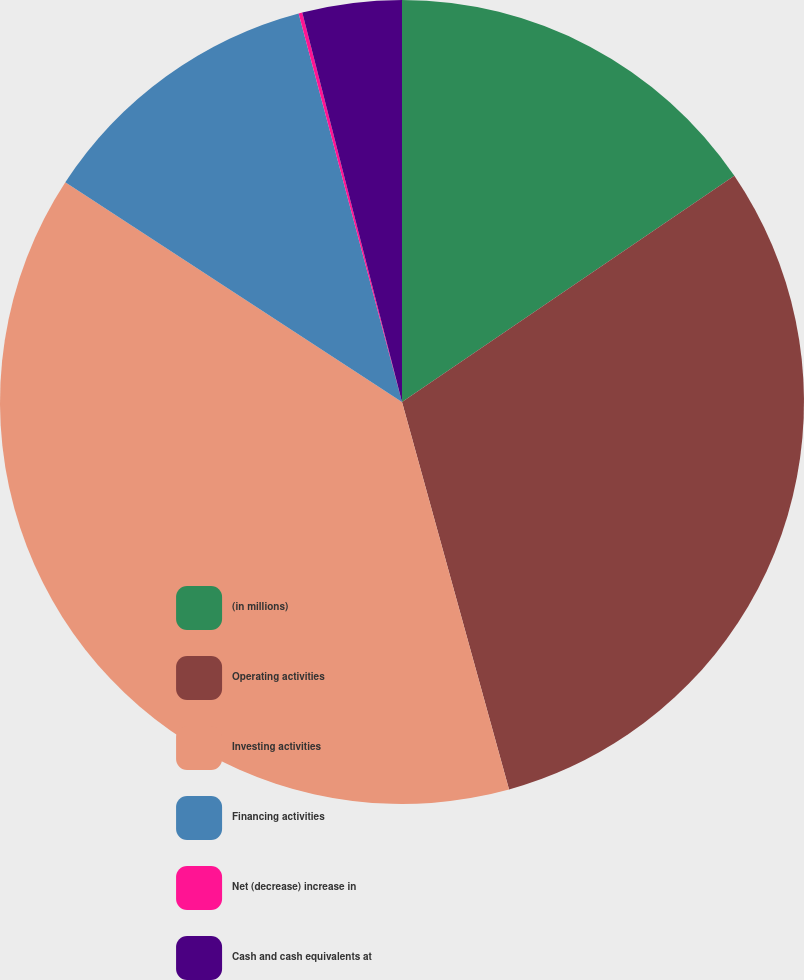<chart> <loc_0><loc_0><loc_500><loc_500><pie_chart><fcel>(in millions)<fcel>Operating activities<fcel>Investing activities<fcel>Financing activities<fcel>Net (decrease) increase in<fcel>Cash and cash equivalents at<nl><fcel>15.49%<fcel>30.22%<fcel>38.49%<fcel>11.66%<fcel>0.15%<fcel>3.99%<nl></chart> 